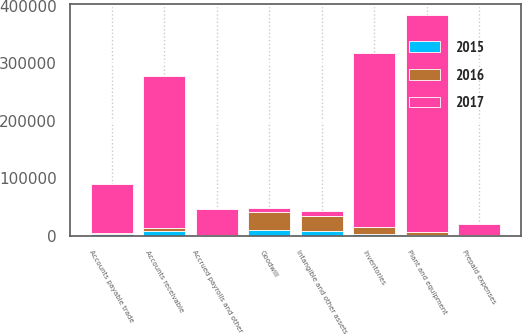Convert chart. <chart><loc_0><loc_0><loc_500><loc_500><stacked_bar_chart><ecel><fcel>Accounts receivable<fcel>Inventories<fcel>Prepaid expenses<fcel>Plant and equipment<fcel>Intangible and other assets<fcel>Goodwill<fcel>Accounts payable trade<fcel>Accrued payrolls and other<nl><fcel>2017<fcel>263616<fcel>302422<fcel>18342<fcel>376826<fcel>7725<fcel>7725<fcel>84753<fcel>45942<nl><fcel>2016<fcel>6793<fcel>12041<fcel>1350<fcel>5647<fcel>26849<fcel>31134<fcel>2536<fcel>1310<nl><fcel>2015<fcel>7656<fcel>3099<fcel>91<fcel>1123<fcel>7794<fcel>10430<fcel>2689<fcel>243<nl></chart> 